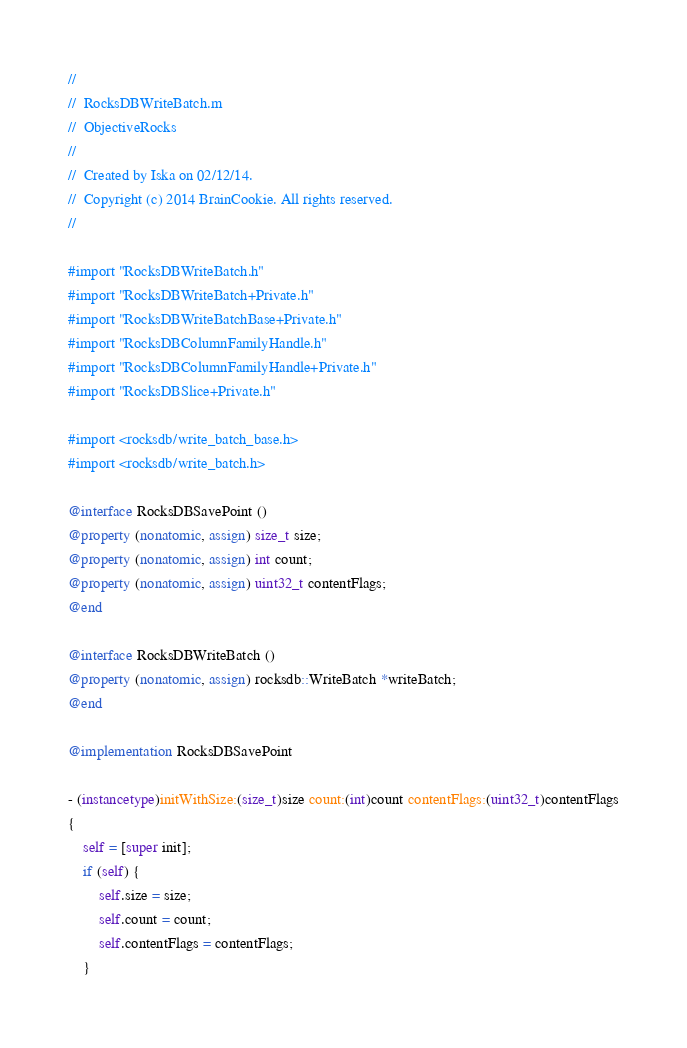Convert code to text. <code><loc_0><loc_0><loc_500><loc_500><_ObjectiveC_>//
//  RocksDBWriteBatch.m
//  ObjectiveRocks
//
//  Created by Iska on 02/12/14.
//  Copyright (c) 2014 BrainCookie. All rights reserved.
//

#import "RocksDBWriteBatch.h"
#import "RocksDBWriteBatch+Private.h"
#import "RocksDBWriteBatchBase+Private.h"
#import "RocksDBColumnFamilyHandle.h"
#import "RocksDBColumnFamilyHandle+Private.h"
#import "RocksDBSlice+Private.h"

#import <rocksdb/write_batch_base.h>
#import <rocksdb/write_batch.h>

@interface RocksDBSavePoint ()
@property (nonatomic, assign) size_t size;
@property (nonatomic, assign) int count;
@property (nonatomic, assign) uint32_t contentFlags;
@end

@interface RocksDBWriteBatch ()
@property (nonatomic, assign) rocksdb::WriteBatch *writeBatch;
@end

@implementation RocksDBSavePoint

- (instancetype)initWithSize:(size_t)size count:(int)count contentFlags:(uint32_t)contentFlags
{
	self = [super init];
	if (self) {
		self.size = size;
		self.count = count;
		self.contentFlags = contentFlags;
	}</code> 